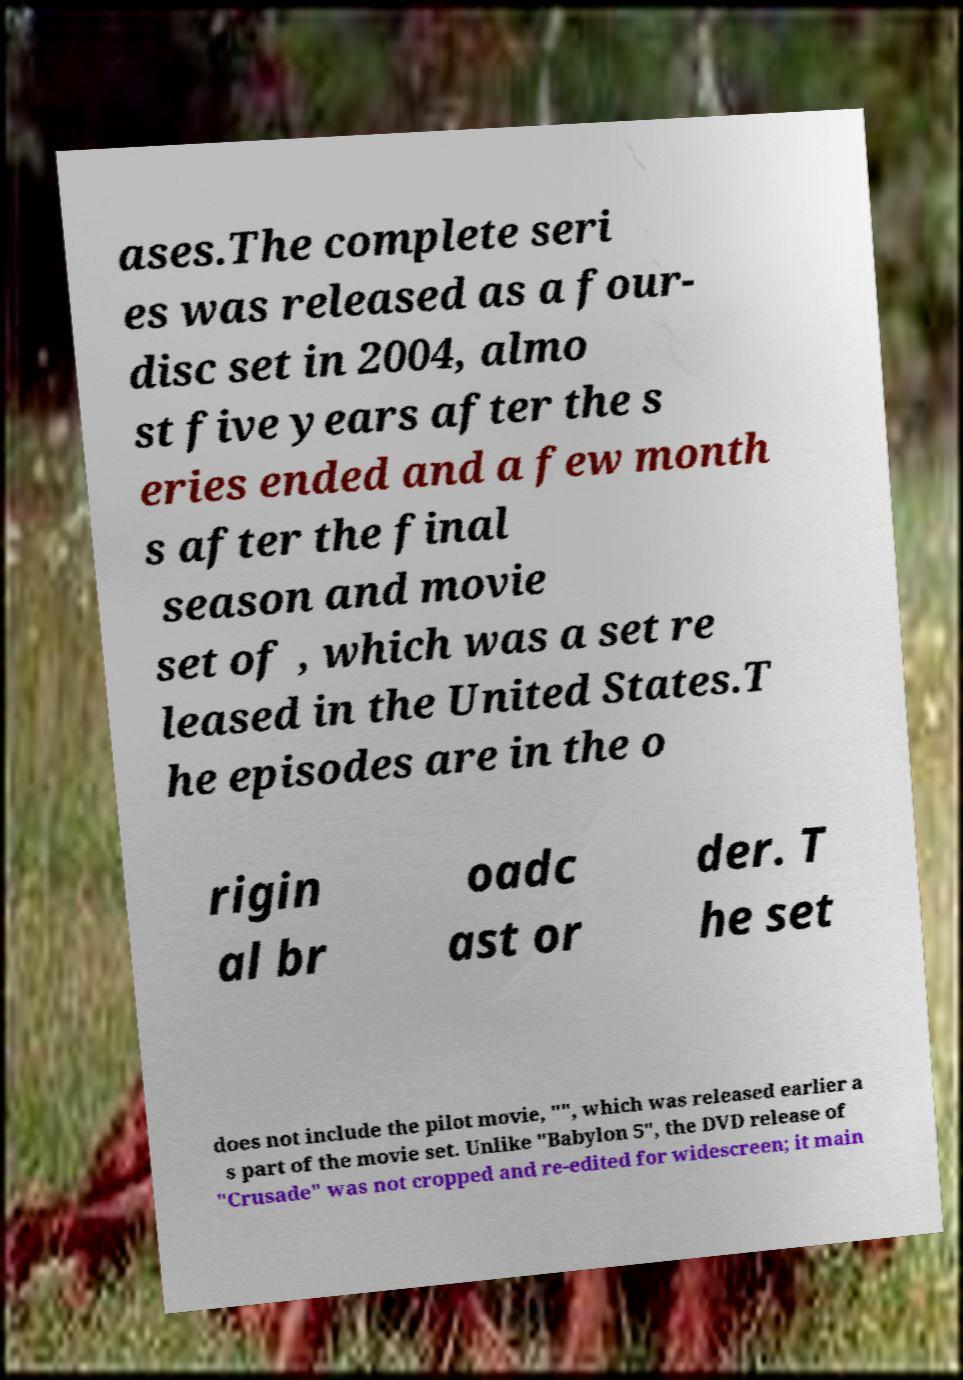I need the written content from this picture converted into text. Can you do that? ases.The complete seri es was released as a four- disc set in 2004, almo st five years after the s eries ended and a few month s after the final season and movie set of , which was a set re leased in the United States.T he episodes are in the o rigin al br oadc ast or der. T he set does not include the pilot movie, "", which was released earlier a s part of the movie set. Unlike "Babylon 5", the DVD release of "Crusade" was not cropped and re-edited for widescreen; it main 